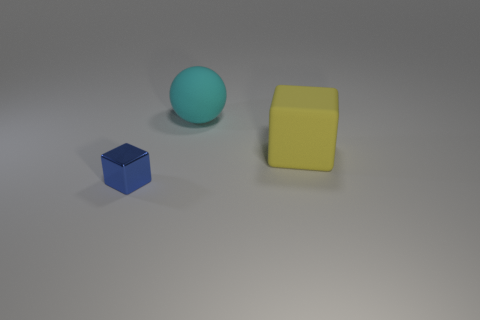Is the size of the cube on the right side of the tiny shiny block the same as the object that is on the left side of the sphere?
Your response must be concise. No. How many other things are there of the same shape as the cyan matte thing?
Provide a succinct answer. 0. There is a cube that is in front of the big rubber thing in front of the cyan rubber ball; what is its material?
Provide a short and direct response. Metal. What number of matte things are large objects or small red things?
Your answer should be compact. 2. Is there any other thing that is the same material as the cyan sphere?
Ensure brevity in your answer.  Yes. Are there any yellow blocks that are in front of the rubber object that is in front of the cyan object?
Make the answer very short. No. What number of objects are either big things in front of the cyan rubber ball or objects behind the small blue thing?
Your answer should be compact. 2. Is there anything else that is the same color as the tiny block?
Keep it short and to the point. No. The big thing in front of the big thing that is behind the cube that is on the right side of the small cube is what color?
Your answer should be compact. Yellow. How big is the block that is on the right side of the cube in front of the large cube?
Make the answer very short. Large. 